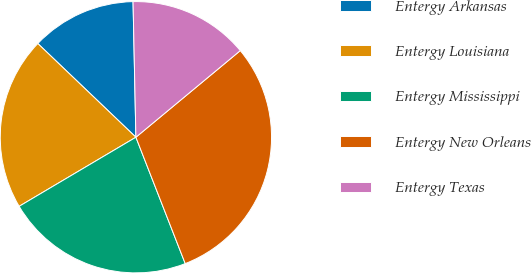Convert chart. <chart><loc_0><loc_0><loc_500><loc_500><pie_chart><fcel>Entergy Arkansas<fcel>Entergy Louisiana<fcel>Entergy Mississippi<fcel>Entergy New Orleans<fcel>Entergy Texas<nl><fcel>12.53%<fcel>20.64%<fcel>22.42%<fcel>30.1%<fcel>14.31%<nl></chart> 